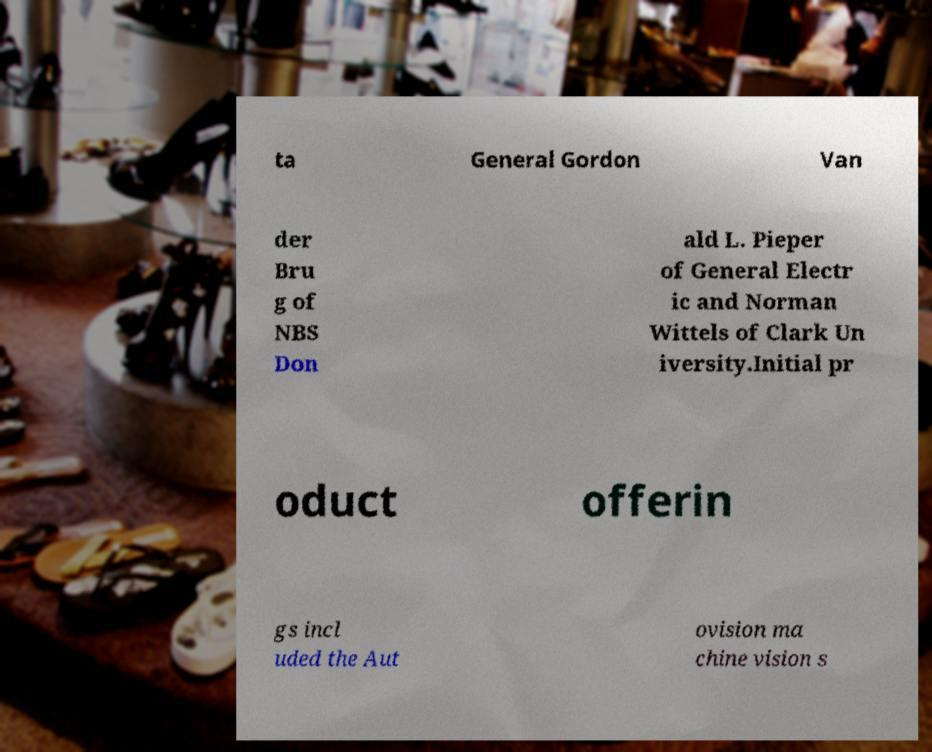Could you assist in decoding the text presented in this image and type it out clearly? ta General Gordon Van der Bru g of NBS Don ald L. Pieper of General Electr ic and Norman Wittels of Clark Un iversity.Initial pr oduct offerin gs incl uded the Aut ovision ma chine vision s 